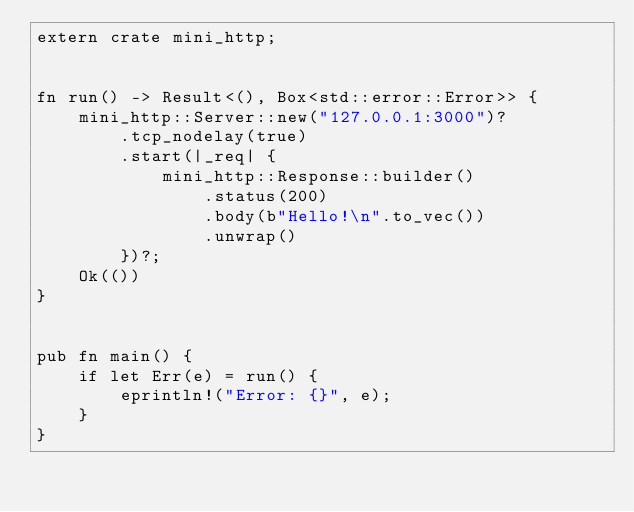<code> <loc_0><loc_0><loc_500><loc_500><_Rust_>extern crate mini_http;


fn run() -> Result<(), Box<std::error::Error>> {
    mini_http::Server::new("127.0.0.1:3000")?
        .tcp_nodelay(true)
        .start(|_req| {
            mini_http::Response::builder()
                .status(200)
                .body(b"Hello!\n".to_vec())
                .unwrap()
        })?;
    Ok(())
}


pub fn main() {
    if let Err(e) = run() {
        eprintln!("Error: {}", e);
    }
}

</code> 